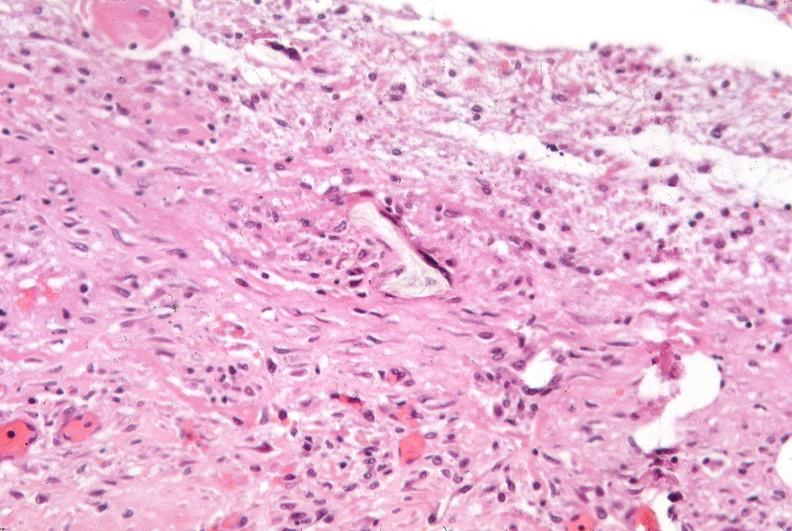what was used to sclerose emphysematous lung, alpha-1 antitrypsin deficiency?
Answer the question using a single word or phrase. Talc 